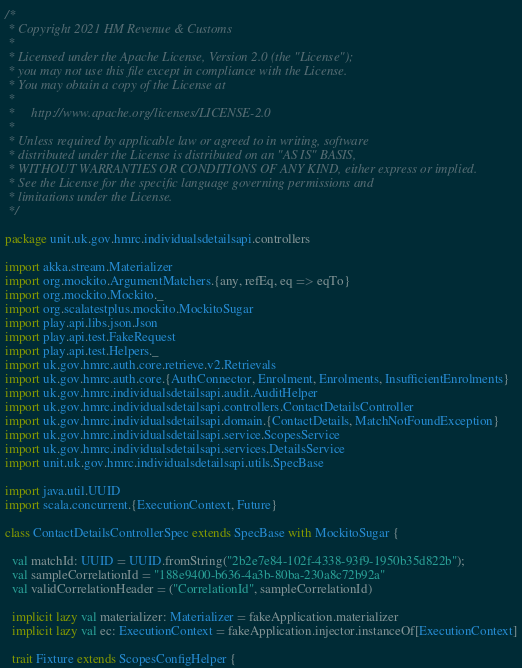Convert code to text. <code><loc_0><loc_0><loc_500><loc_500><_Scala_>/*
 * Copyright 2021 HM Revenue & Customs
 *
 * Licensed under the Apache License, Version 2.0 (the "License");
 * you may not use this file except in compliance with the License.
 * You may obtain a copy of the License at
 *
 *     http://www.apache.org/licenses/LICENSE-2.0
 *
 * Unless required by applicable law or agreed to in writing, software
 * distributed under the License is distributed on an "AS IS" BASIS,
 * WITHOUT WARRANTIES OR CONDITIONS OF ANY KIND, either express or implied.
 * See the License for the specific language governing permissions and
 * limitations under the License.
 */

package unit.uk.gov.hmrc.individualsdetailsapi.controllers

import akka.stream.Materializer
import org.mockito.ArgumentMatchers.{any, refEq, eq => eqTo}
import org.mockito.Mockito._
import org.scalatestplus.mockito.MockitoSugar
import play.api.libs.json.Json
import play.api.test.FakeRequest
import play.api.test.Helpers._
import uk.gov.hmrc.auth.core.retrieve.v2.Retrievals
import uk.gov.hmrc.auth.core.{AuthConnector, Enrolment, Enrolments, InsufficientEnrolments}
import uk.gov.hmrc.individualsdetailsapi.audit.AuditHelper
import uk.gov.hmrc.individualsdetailsapi.controllers.ContactDetailsController
import uk.gov.hmrc.individualsdetailsapi.domain.{ContactDetails, MatchNotFoundException}
import uk.gov.hmrc.individualsdetailsapi.service.ScopesService
import uk.gov.hmrc.individualsdetailsapi.services.DetailsService
import unit.uk.gov.hmrc.individualsdetailsapi.utils.SpecBase

import java.util.UUID
import scala.concurrent.{ExecutionContext, Future}

class ContactDetailsControllerSpec extends SpecBase with MockitoSugar {

  val matchId: UUID = UUID.fromString("2b2e7e84-102f-4338-93f9-1950b35d822b");
  val sampleCorrelationId = "188e9400-b636-4a3b-80ba-230a8c72b92a"
  val validCorrelationHeader = ("CorrelationId", sampleCorrelationId)

  implicit lazy val materializer: Materializer = fakeApplication.materializer
  implicit lazy val ec: ExecutionContext = fakeApplication.injector.instanceOf[ExecutionContext]

  trait Fixture extends ScopesConfigHelper {
</code> 